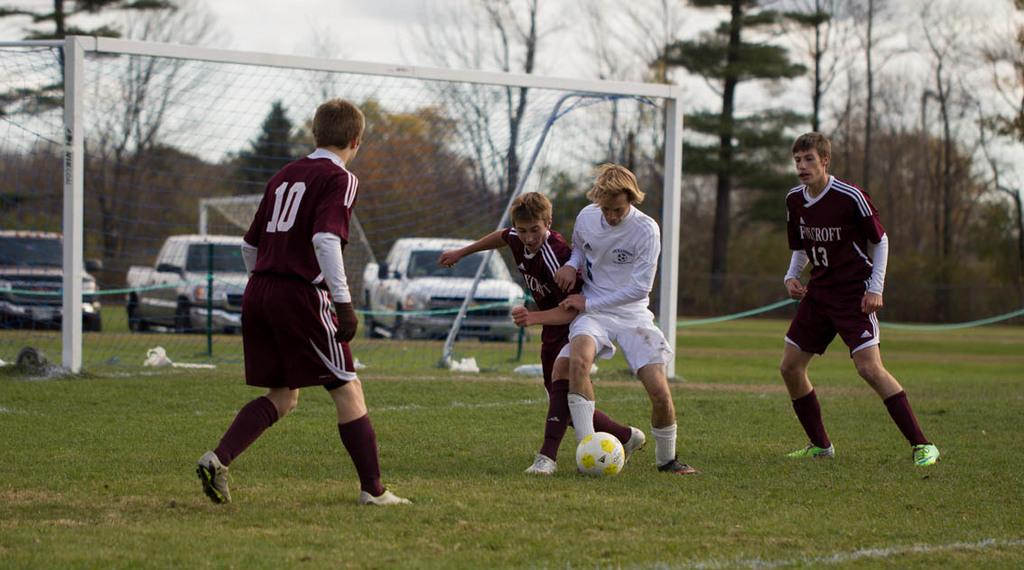What are the four people in the image doing? The four people in the image are playing football. What can be seen in the background of the image? There is a car and trees visible in the background of the image. Where is the turkey sitting in the image? There is no turkey present in the image. What type of bat is flying in the image? There are no bats present in the image. 